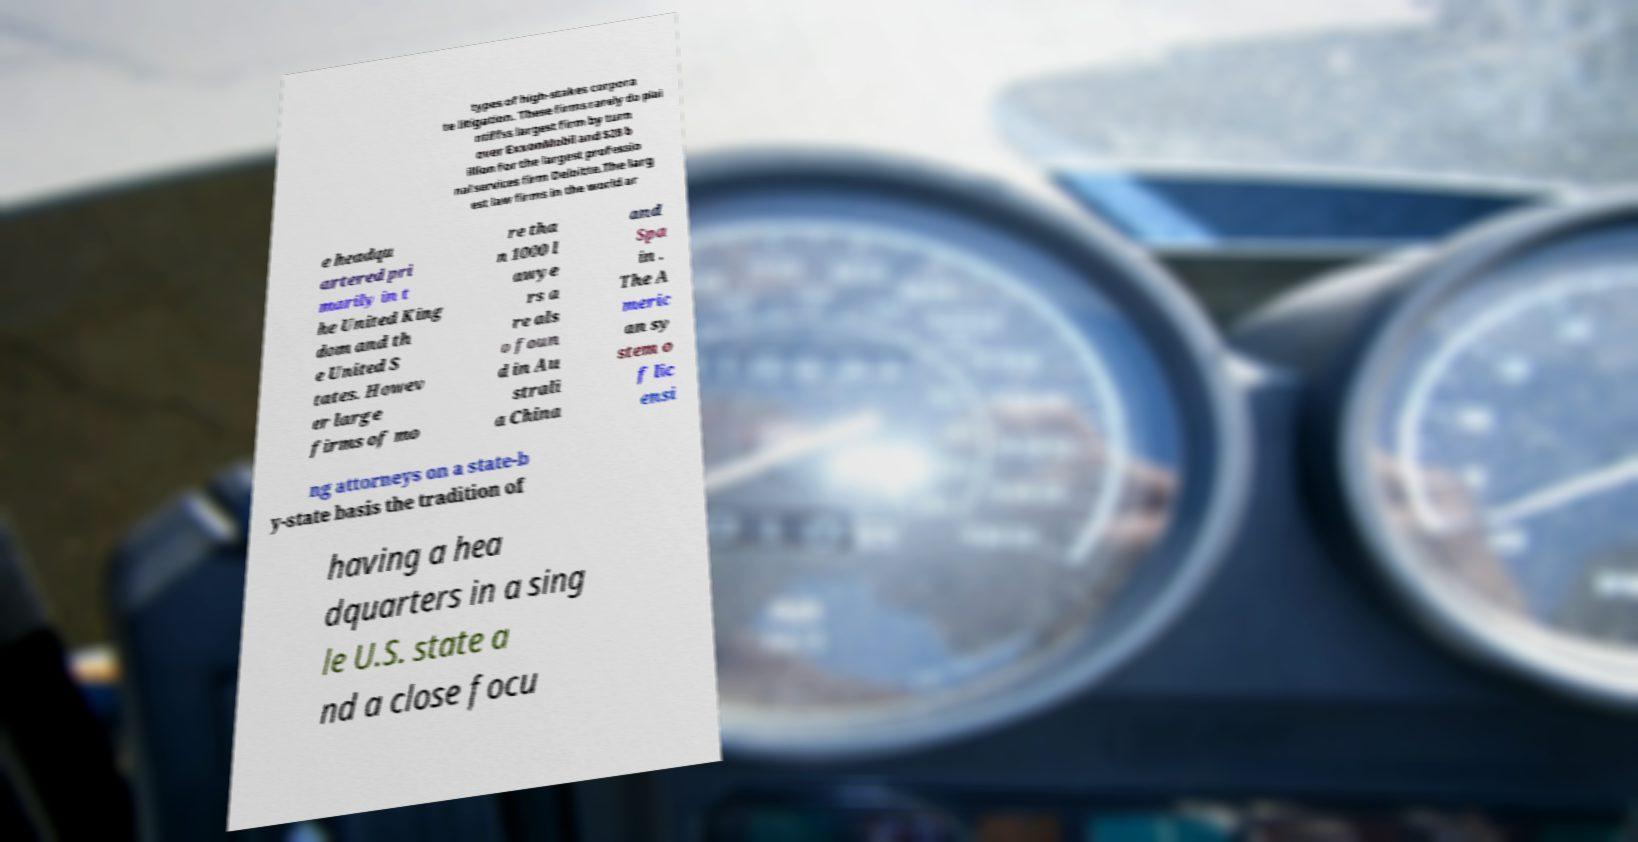Could you extract and type out the text from this image? types of high-stakes corpora te litigation. These firms rarely do plai ntiffss largest firm by turn over ExxonMobil and $28 b illion for the largest professio nal services firm Deloitte.The larg est law firms in the world ar e headqu artered pri marily in t he United King dom and th e United S tates. Howev er large firms of mo re tha n 1000 l awye rs a re als o foun d in Au strali a China and Spa in . The A meric an sy stem o f lic ensi ng attorneys on a state-b y-state basis the tradition of having a hea dquarters in a sing le U.S. state a nd a close focu 